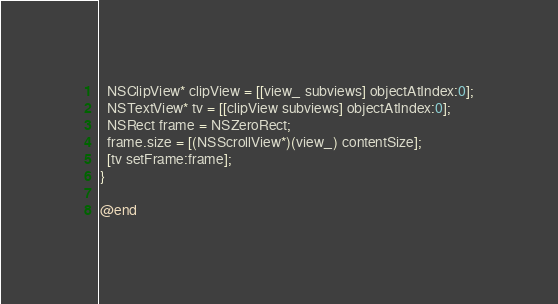Convert code to text. <code><loc_0><loc_0><loc_500><loc_500><_ObjectiveC_>  NSClipView* clipView = [[view_ subviews] objectAtIndex:0];
  NSTextView* tv = [[clipView subviews] objectAtIndex:0];
  NSRect frame = NSZeroRect;
  frame.size = [(NSScrollView*)(view_) contentSize];
  [tv setFrame:frame];
}

@end
</code> 